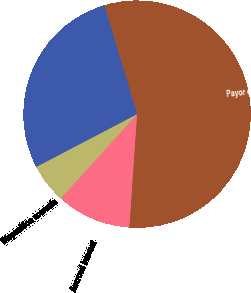Convert chart to OTSL. <chart><loc_0><loc_0><loc_500><loc_500><pie_chart><fcel>Payor deferrals and refunds<fcel>Accrued interest<fcel>Disposition accruals<fcel>Other<nl><fcel>55.74%<fcel>10.62%<fcel>5.61%<fcel>28.03%<nl></chart> 